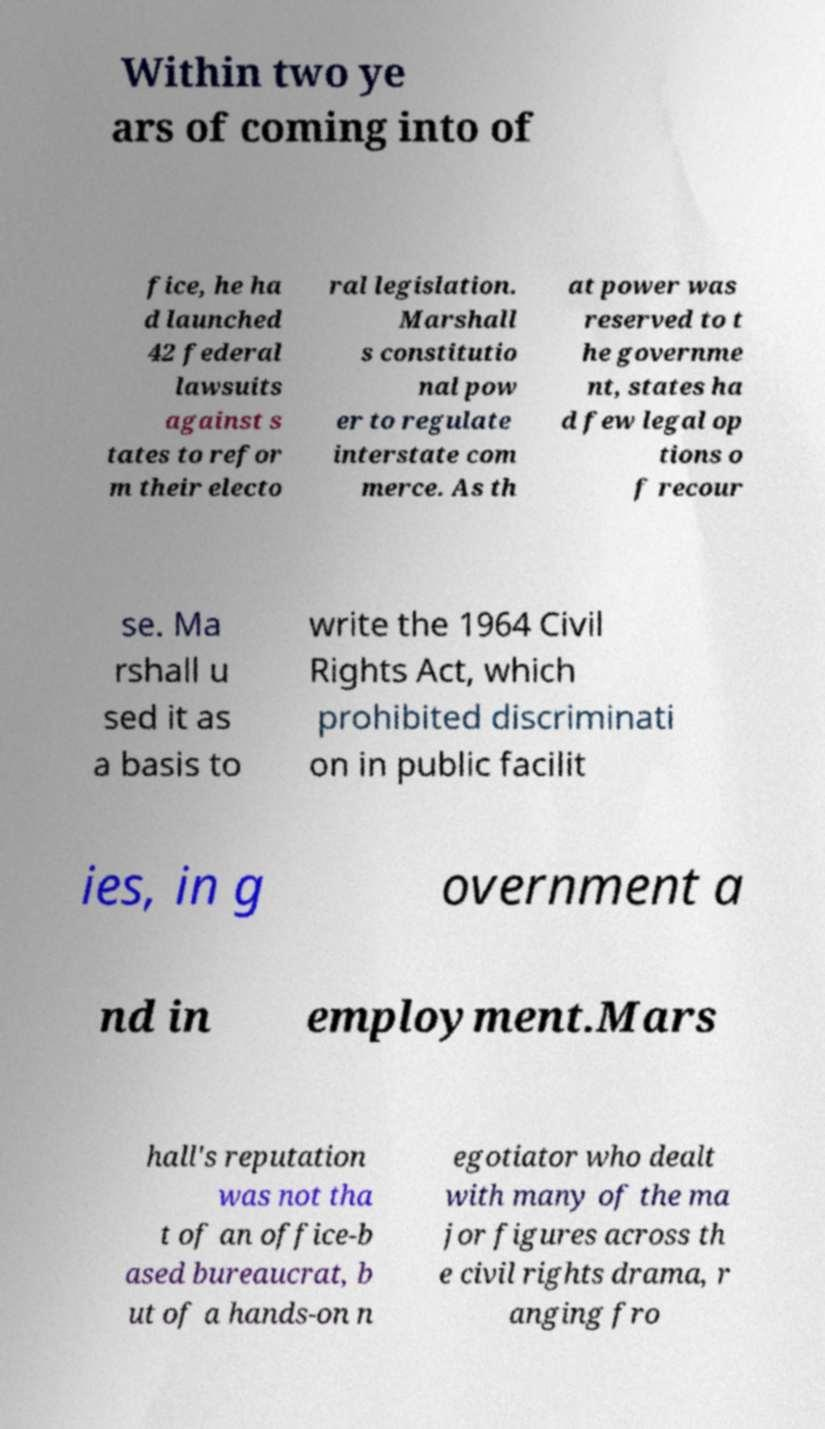Please identify and transcribe the text found in this image. Within two ye ars of coming into of fice, he ha d launched 42 federal lawsuits against s tates to refor m their electo ral legislation. Marshall s constitutio nal pow er to regulate interstate com merce. As th at power was reserved to t he governme nt, states ha d few legal op tions o f recour se. Ma rshall u sed it as a basis to write the 1964 Civil Rights Act, which prohibited discriminati on in public facilit ies, in g overnment a nd in employment.Mars hall's reputation was not tha t of an office-b ased bureaucrat, b ut of a hands-on n egotiator who dealt with many of the ma jor figures across th e civil rights drama, r anging fro 